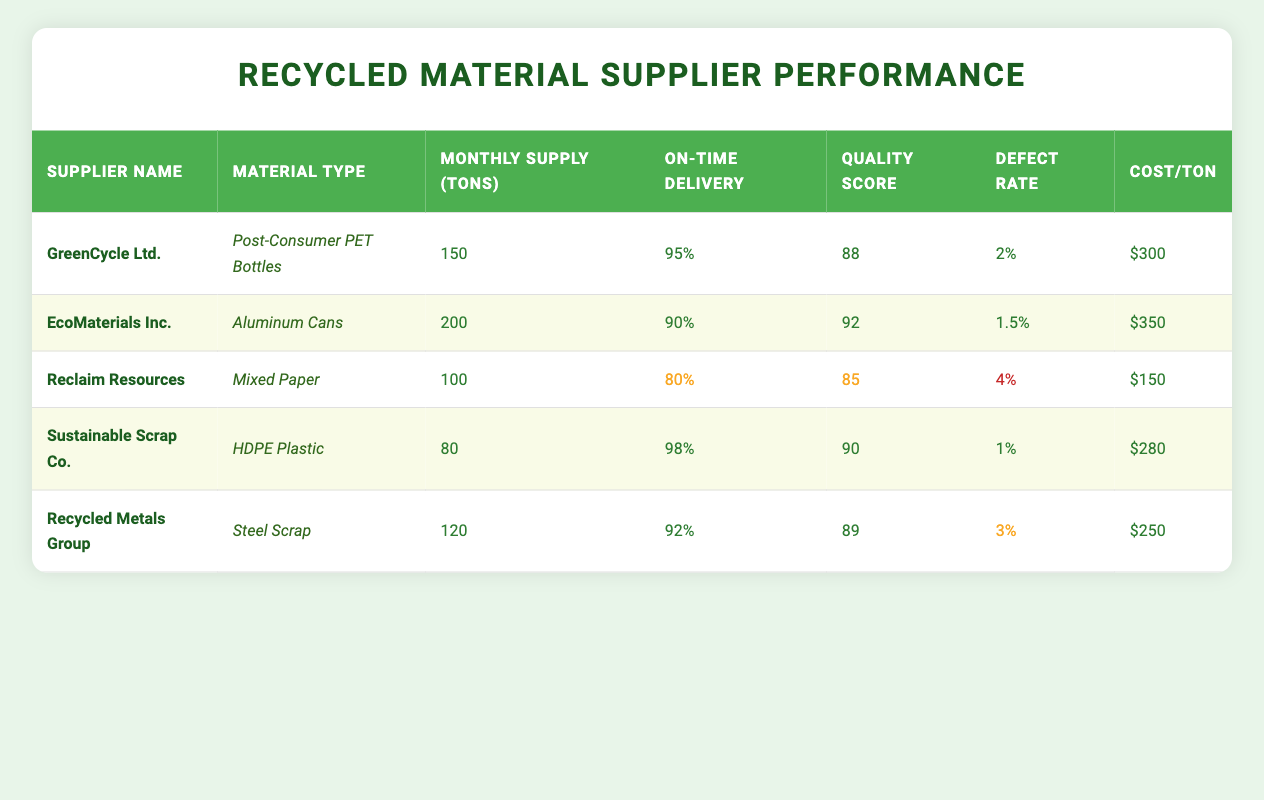What is the cost per ton of HDPE Plastic from Sustainable Scrap Co.? The table clearly shows that the cost per ton for HDPE Plastic from Sustainable Scrap Co. is $280.
Answer: $280 What material type does EcoMaterials Inc. supply? Referring to the table, EcoMaterials Inc. is identified as supplying Aluminum Cans.
Answer: Aluminum Cans Which supplier has the highest on-time delivery percentage? By comparing the on-time delivery percentages listed in the table, Sustainable Scrap Co. has the highest percentage at 98%.
Answer: 98% What is the average monthly supply volume from all suppliers? To find the average, first sum the monthly supply volumes: 150 + 200 + 100 + 80 + 120 = 650. Then divide by the number of suppliers (5): 650 / 5 = 130.
Answer: 130 tons Does GreenCycle Ltd. have a defect rate lower than 3%? The defect rate for GreenCycle Ltd. is listed as 2%, which is indeed lower than 3%.
Answer: Yes Which supplier has the lowest material quality score and what is it? By examining the quality scores, Reclaim Resources has the lowest score at 85.
Answer: 85 If we consider only the suppliers with a defect rate lower than 2%, how many suppliers meet this criterion? The defect rates are as follows: GreenCycle Ltd. (2%), EcoMaterials Inc. (1.5%), Sustainable Scrap Co. (1%), and Recycled Metals Group (3%). Only EcoMaterials Inc. and Sustainable Scrap Co. have defect rates lower than 2%, totaling 2 suppliers.
Answer: 2 suppliers What is the difference between the highest and lowest monthly supply volume? The highest monthly supply volume is from EcoMaterials Inc. at 200 tons, and the lowest is from Sustainable Scrap Co. at 80 tons. The difference is calculated by subtracting the lower value from the higher one: 200 - 80 = 120.
Answer: 120 tons Is it true that Reclaim Resources supplies more than 100 tons of material monthly? The table indicates that Reclaim Resources has a monthly supply volume of 100 tons, which does not exceed 100 tons.
Answer: No 